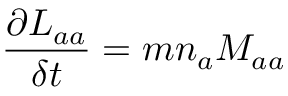Convert formula to latex. <formula><loc_0><loc_0><loc_500><loc_500>\frac { \partial L _ { a a } } { \delta t } = m n _ { a } M _ { a a }</formula> 